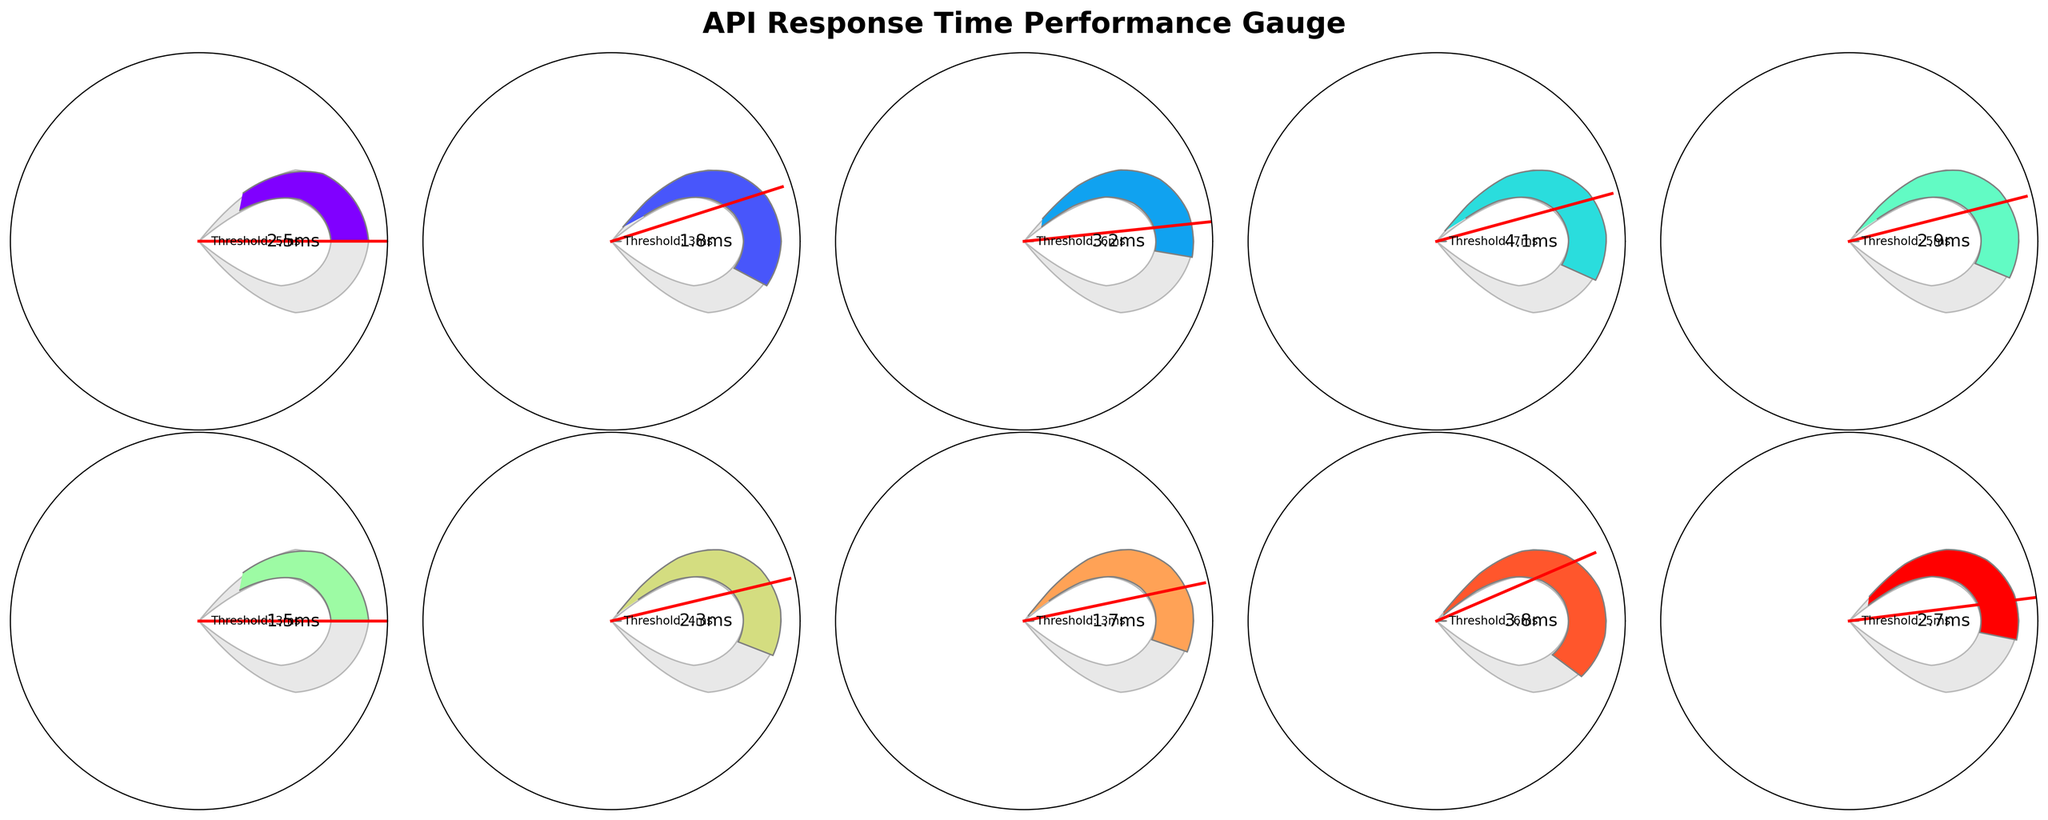What is the title of the figure? The title is displayed at the top of the figure in bold and larger font size. It reads "API Response Time Performance Gauge".
Answer: API Response Time Performance Gauge What is the response time for the 'OrderExecution' API endpoint? Locate the 'OrderExecution' gauge in the figure, and read the response time displayed near its center. It shows 2.5 ms.
Answer: 2.5 ms Which API endpoint has the highest response time? Compare all gauges by looking at the response time values displayed near their centers. 'RiskAssessment' has the highest response time of 4.1 ms.
Answer: RiskAssessment Which API endpoint has the smallest threshold? Look at the threshold values displayed near the center of each gauge. 'MarketDataFeed', 'PriceQuote', and 'AccountBalance' all share the smallest threshold of 3 ms.
Answer: MarketDataFeed, PriceQuote, AccountBalance How many API endpoints have response times greater than 3 milliseconds? Count the gauges where the response time value displayed near the center is greater than 3 ms. These are 'PortfolioValuation', 'RiskAssessment', and 'AlgorithmicStrategy'. There are 3 such endpoints.
Answer: 3 Which API endpoint has the largest difference between its response time and threshold? Calculate the difference between response time and threshold for each endpoint, and identify the one with the largest difference ('RiskAssessment' with response time of 4.1 ms and threshold of 7 ms, difference being 7 - 4.1 = 2.9 ms).
Answer: RiskAssessment What is the average threshold value across all API endpoints? Sum the threshold values of all API endpoints and divide by the total number of endpoints (5 + 3 + 6 + 7 + 5 + 3 + 4 + 3 + 6 + 5) / 10 = 47 / 10 = 4.7
Answer: 4.7 Is the response time for 'AlgorithmicStrategy' within its threshold? Compare the 'AlgorithmicStrategy' response time (3.8 ms) with its threshold (6 ms). Since 3.8 < 6, it is within the threshold.
Answer: Yes How many endpoints have their response times equal to their thresholds? Count the number of gauges where the response time is equal to the threshold. None of the response times are equal to their thresholds.
Answer: 0 Which endpoints' response times are less than 2 milliseconds? Identify endpoints with response times less than 2 ms. These are 'MarketDataFeed', 'PriceQuote', and 'AccountBalance'.
Answer: MarketDataFeed, PriceQuote, AccountBalance 